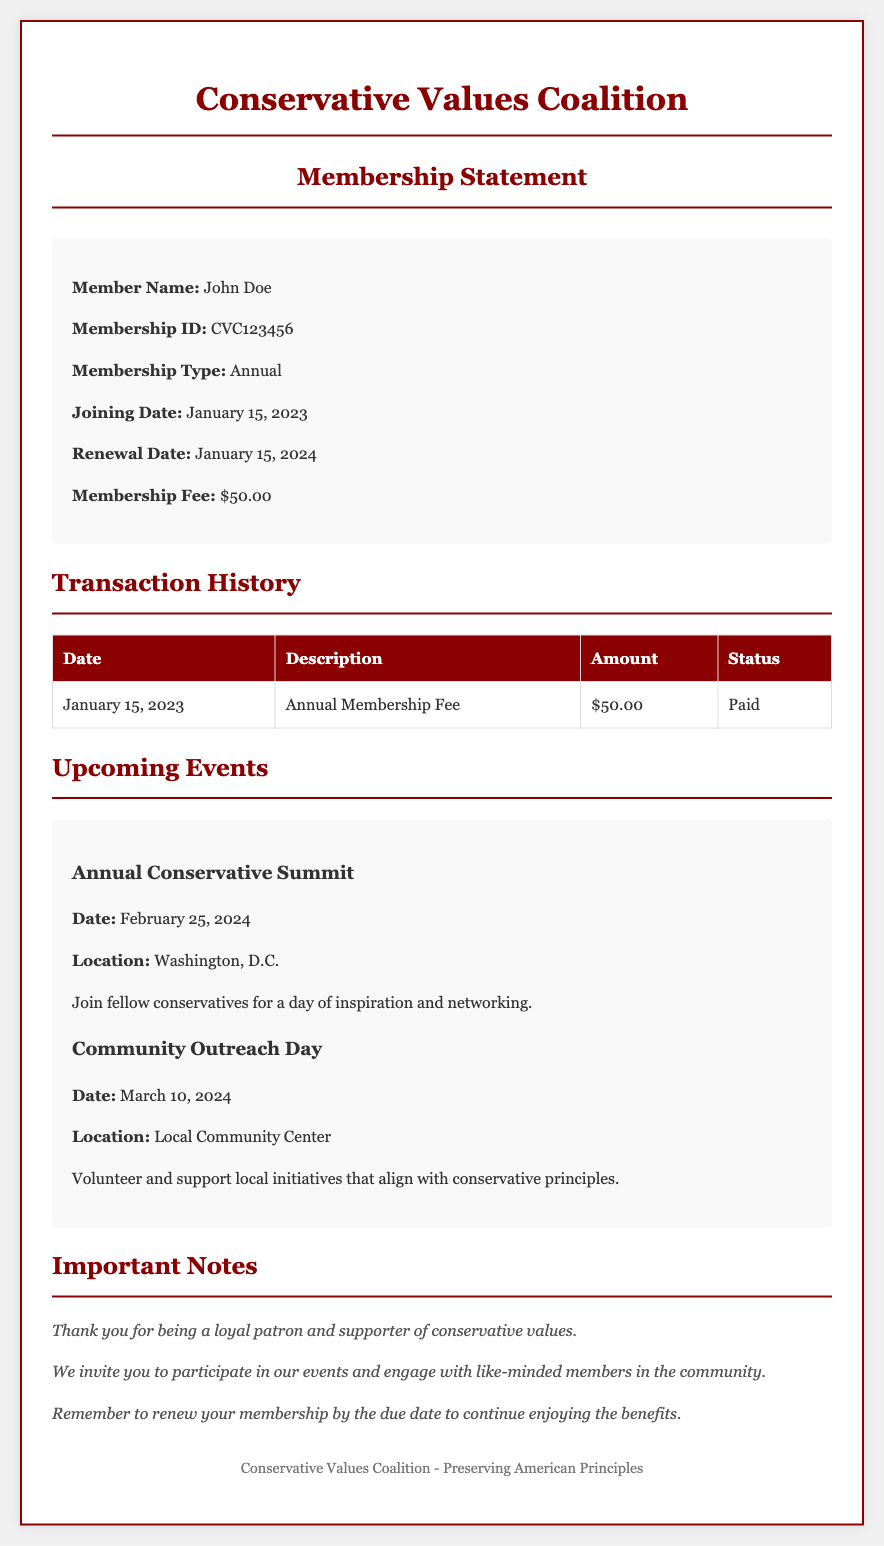What is the member's name? The member's name is prominently displayed in the member info section of the document.
Answer: John Doe What is the membership ID? The membership ID can be found in the member info section right below the member's name.
Answer: CVC123456 When is the renewal date? The renewal date is mentioned in the member info section as the date the membership needs to be renewed.
Answer: January 15, 2024 What is the membership fee? The membership fee is listed under the member info section and indicates the cost of the membership.
Answer: $50.00 How many transactions are in the history? The transaction history section contains details about how many transactions occurred, which can be counted from the table.
Answer: 1 What is the date of the Annual Conservative Summit? The date of the event is provided in the upcoming events section, in the description of the event.
Answer: February 25, 2024 What type of membership does John Doe have? The membership type is specified right in the member info section of the document.
Answer: Annual What does the notes section thank the member for? The notes section includes appreciation towards the member for their continued support, which is crucial for this document type.
Answer: being a loyal patron and supporter of conservative values What is the location of the Community Outreach Day? The location is detailed in the upcoming events section for the Community Outreach Day.
Answer: Local Community Center 